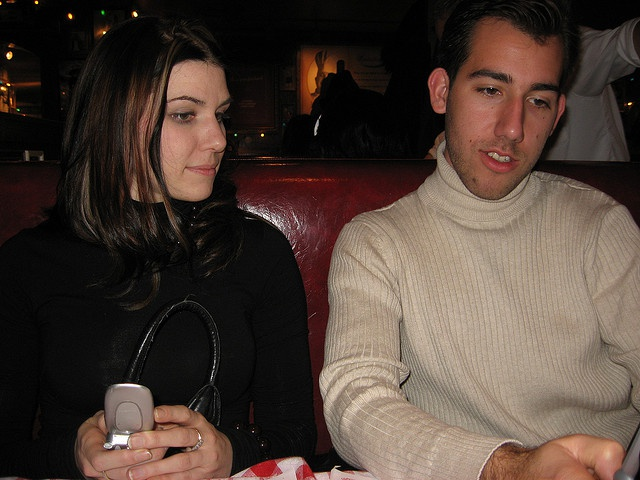Describe the objects in this image and their specific colors. I can see people in black, tan, and gray tones, people in black, gray, salmon, and maroon tones, couch in black, maroon, and gray tones, people in black tones, and cell phone in black and gray tones in this image. 